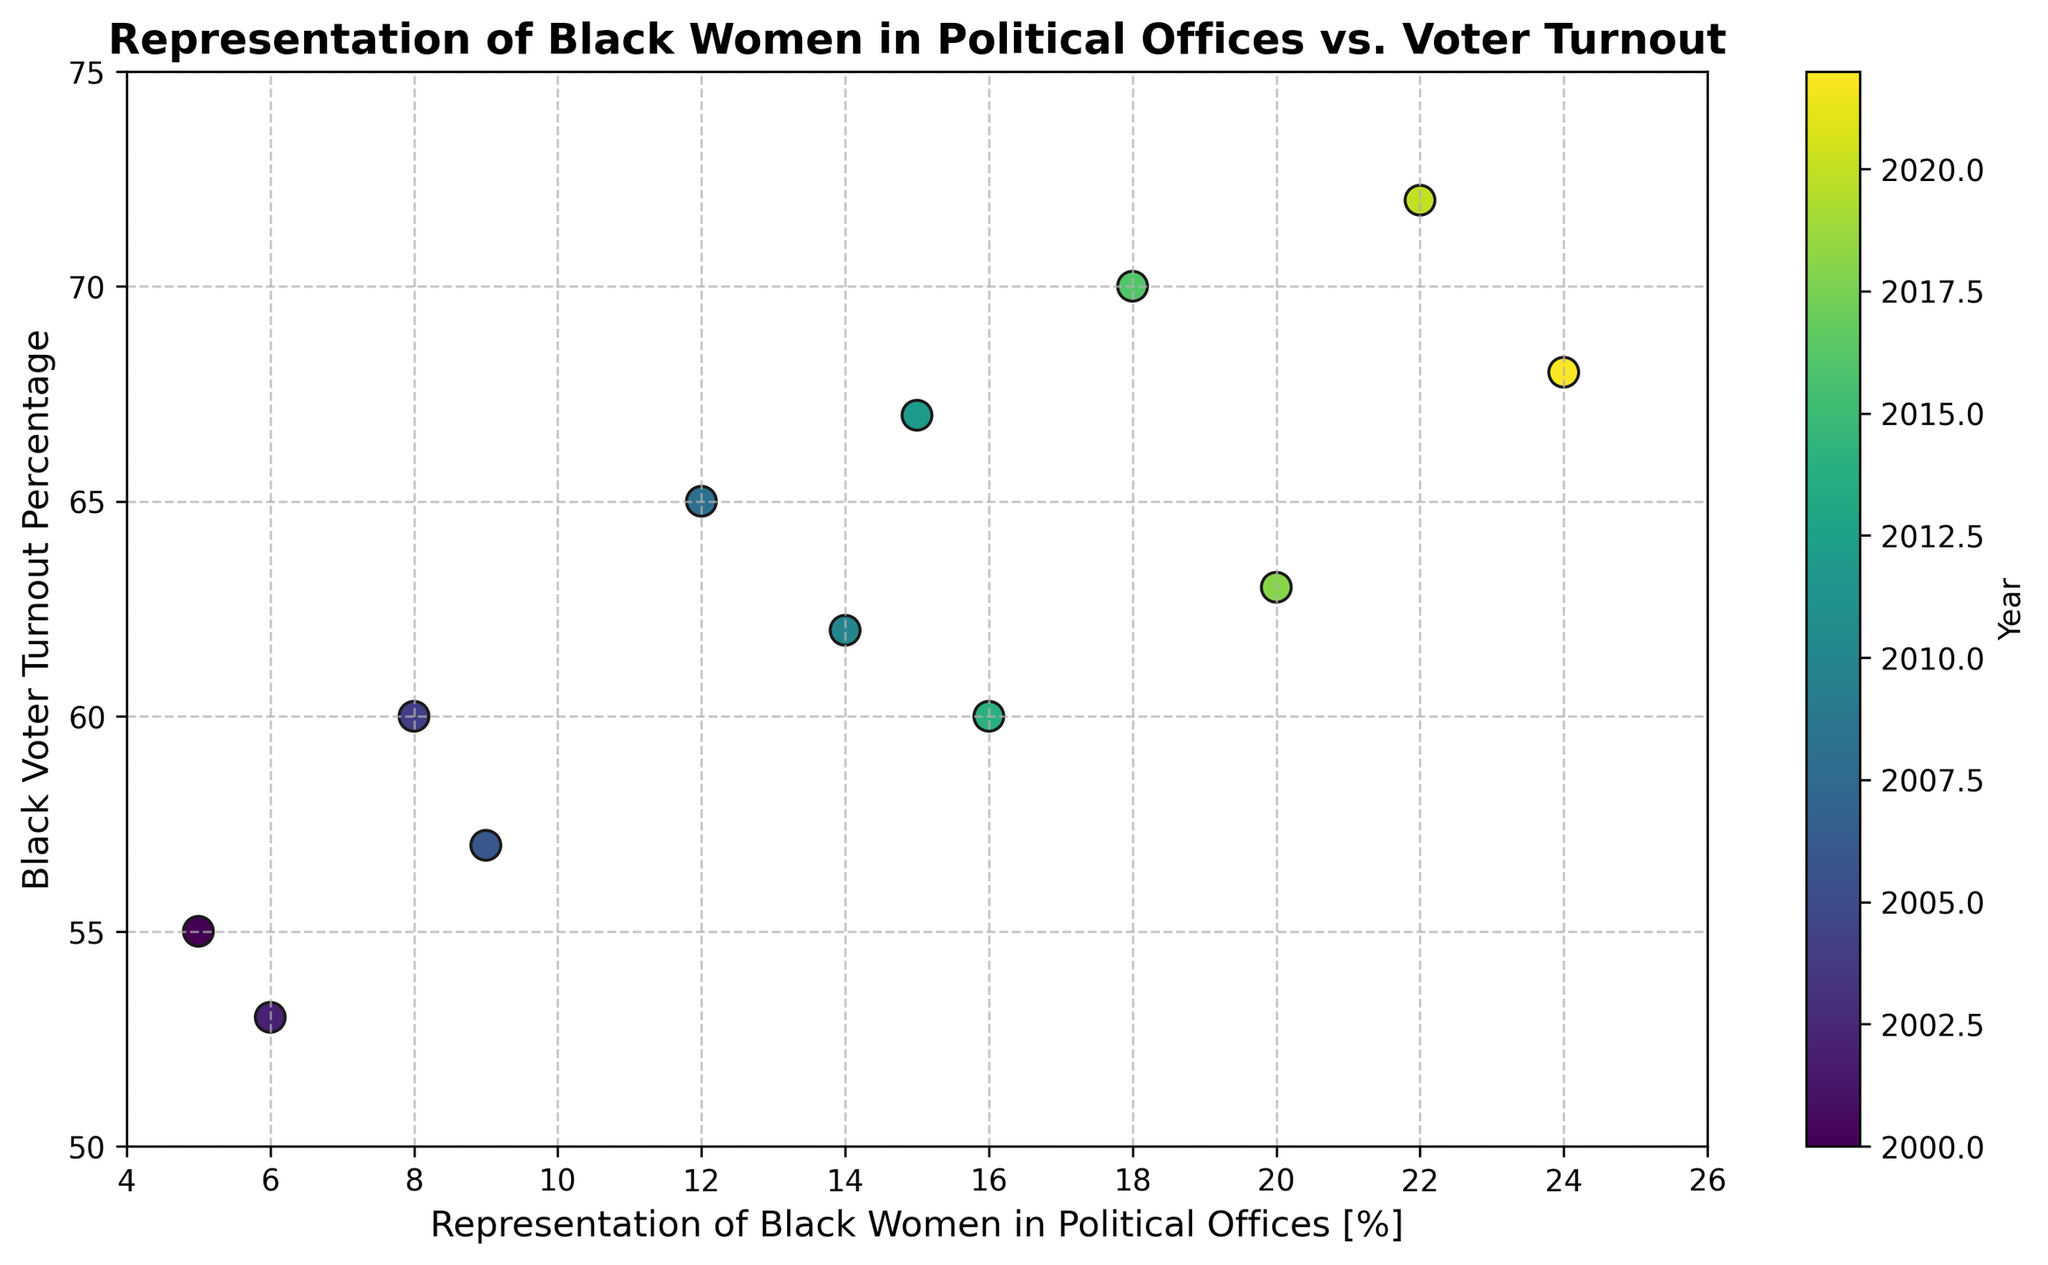What is the general trend of Black voter turnout as the representation of Black women in political offices increases? As the representation of Black women in political offices increases, the Black voter turnout percentage tends to increase as well. This is evident from the positive slope of the scatter plot, where higher representation often aligns with higher voter turnout percentages.
Answer: Upward trend How does the Black voter turnout for the year 2008 compare to the year 2002? In the scatter plot, 2008 is marked with a higher turnout (65%) compared to 2002 (53%). This can be visually confirmed by looking at the color gradient and corresponding positions along the vertical axis.
Answer: 2008 is higher What is the difference in voter turnout percentage between the years with the highest and lowest representation of Black women in political offices? The highest representation is in 2022 (24%), and the lowest is in 2000 (5%). The voter turnout in 2022 is 68%, and in 2000 it is 55%. Thus, the difference is 68% - 55% = 13%.
Answer: 13% Which year had the highest Black voter turnout and what was it? According to the scatter plot, the highest Black voter turnout is in 2020, marked by the highest point along the vertical axis (72%) and verified by the color gradient.
Answer: 2020 with 72% What can be inferred about the relationship between the representation of Black women in political offices and Black voter turnout in 2016 and 2018? In 2016, the representation is 18% with a turnout of 70%. In 2018, the representation increases to 20%, but the turnout decreases to 63%. This suggests that an increase in representation does not always lead to an increase in voter turnout.
Answer: Increase in representation did not increase turnout What is the average Black voter turnout for the years with more than 15% representation of Black women in political offices? Years with more than 15% representation are 2014, 2016, 2018, 2020, and 2022. The voter turnouts are 60%, 70%, 63%, 72%, and 68%. The average turnout is (60 + 70 + 63 + 72 + 68) / 5 = 66.6%.
Answer: 66.6% Which year had a voter turnout close to 60%, and what was the representation of Black women in political offices that year? The year with a voter turnout close to 60% is 2014, with a specific turnout of 60%. The representation of Black women in political offices that year was 16%.
Answer: 2014 with 16% Does there appear to be any outlier points where voter turnout is significantly different from similar representation levels? In the scatter plot, 2018 stands out as an outlier with a turnout of 63% despite a relatively high representation of 20%, which is lower compared to its neighboring years (2016 and 2020) with higher turnouts.
Answer: 2018 Compare the voter turnout between 2004 and 2012 and determine the increase in representation of Black women in political offices during this period. In 2004, the voter turnout was 60% with an 8% representation of Black women in political offices. In 2012, the turnout was 67%, with a 15% representation. The increase in representation is 15% - 8% = 7%.
Answer: Increase by 7% 